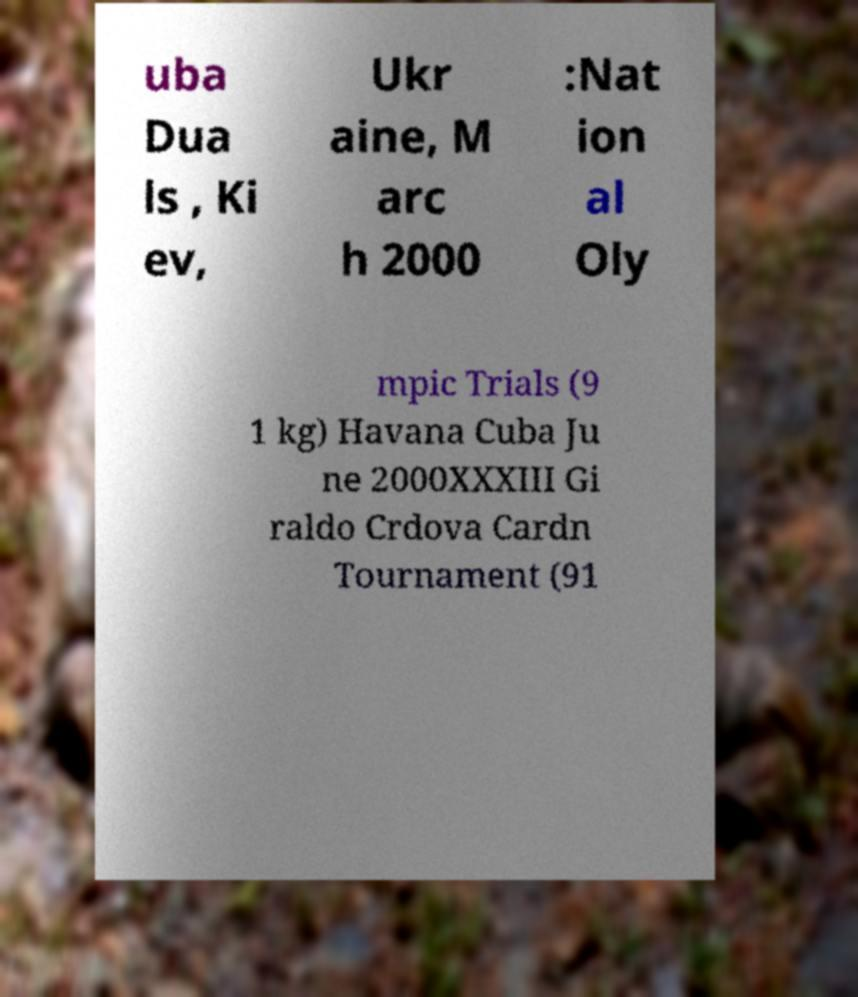Can you accurately transcribe the text from the provided image for me? uba Dua ls , Ki ev, Ukr aine, M arc h 2000 :Nat ion al Oly mpic Trials (9 1 kg) Havana Cuba Ju ne 2000XXXIII Gi raldo Crdova Cardn Tournament (91 